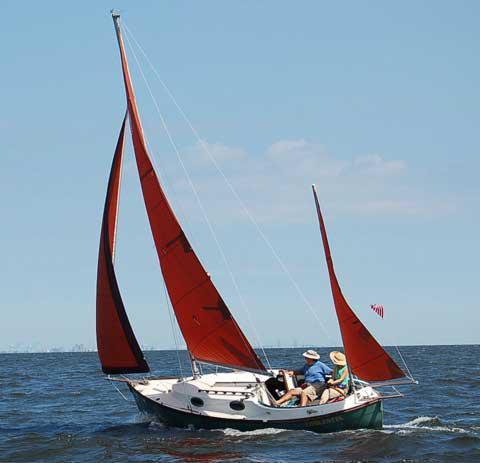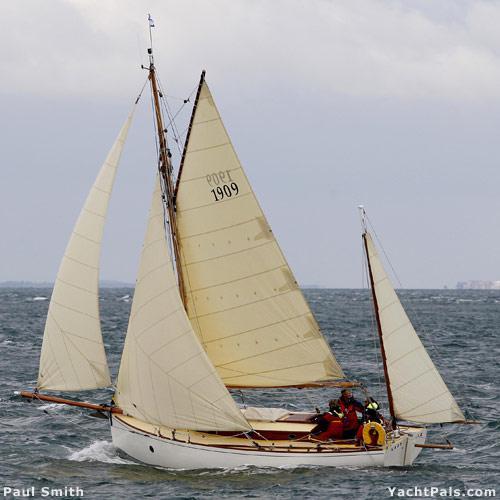The first image is the image on the left, the second image is the image on the right. Examine the images to the left and right. Is the description "A boat on the water with three inflated sails is facing left" accurate? Answer yes or no. Yes. 